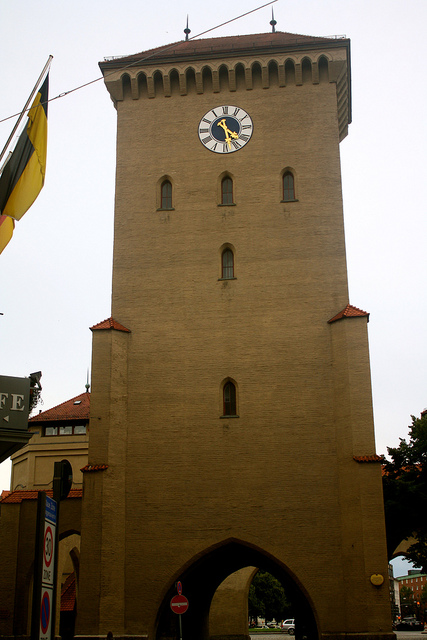Please transcribe the text in this image. FE 